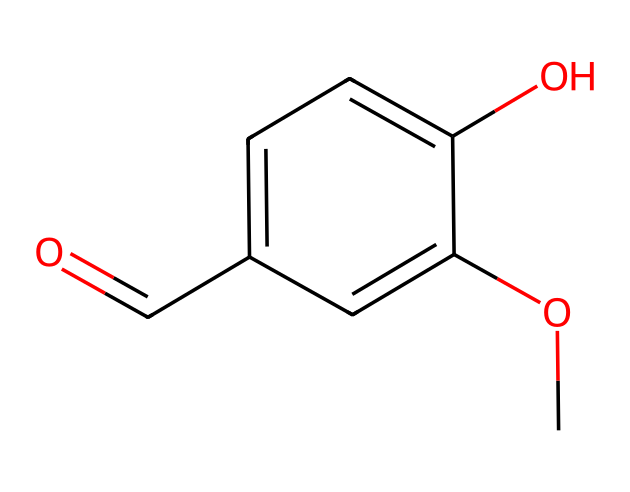How many carbon atoms are in vanillin? By examining the SMILES representation, we can count the carbon atoms. The 'C' before the 'O' indicates a carbon atom, and by analyzing the remaining part of the structure, we find a total of 8 carbon atoms in the entire molecule.
Answer: 8 What functional groups are present in vanillin? In the structure, we can identify a methoxy group (–OCH3) and an aldehyde group (–C=O), indicating that vanillin contains both an ether and an aldehyde functional group.
Answer: ether and aldehyde What is the degree of saturation in vanillin? The degree of saturation can be determined by counting the number of rings and double bonds in the molecule. There is one double bond in the aldehyde functional group and no rings, resulting in a degree of saturation of 7.
Answer: 7 Which part of the structure is responsible for the characteristic aroma of vanilla? The aldehyde functional group (–C=O) is crucial in providing the characteristic aroma of vanilla, as the specific arrangement of atoms in vanillin predominantly contributes to its scent.
Answer: aldehyde group Is vanillin classified as a ketone or an aldehyde? Upon analyzing the structure, we see that the functional group at the terminal end is an aldehyde, characterized by the presence of the carbonyl group (C=O) at the end of the carbon chain, thus categorizing vanillin as an aldehyde.
Answer: aldehyde 